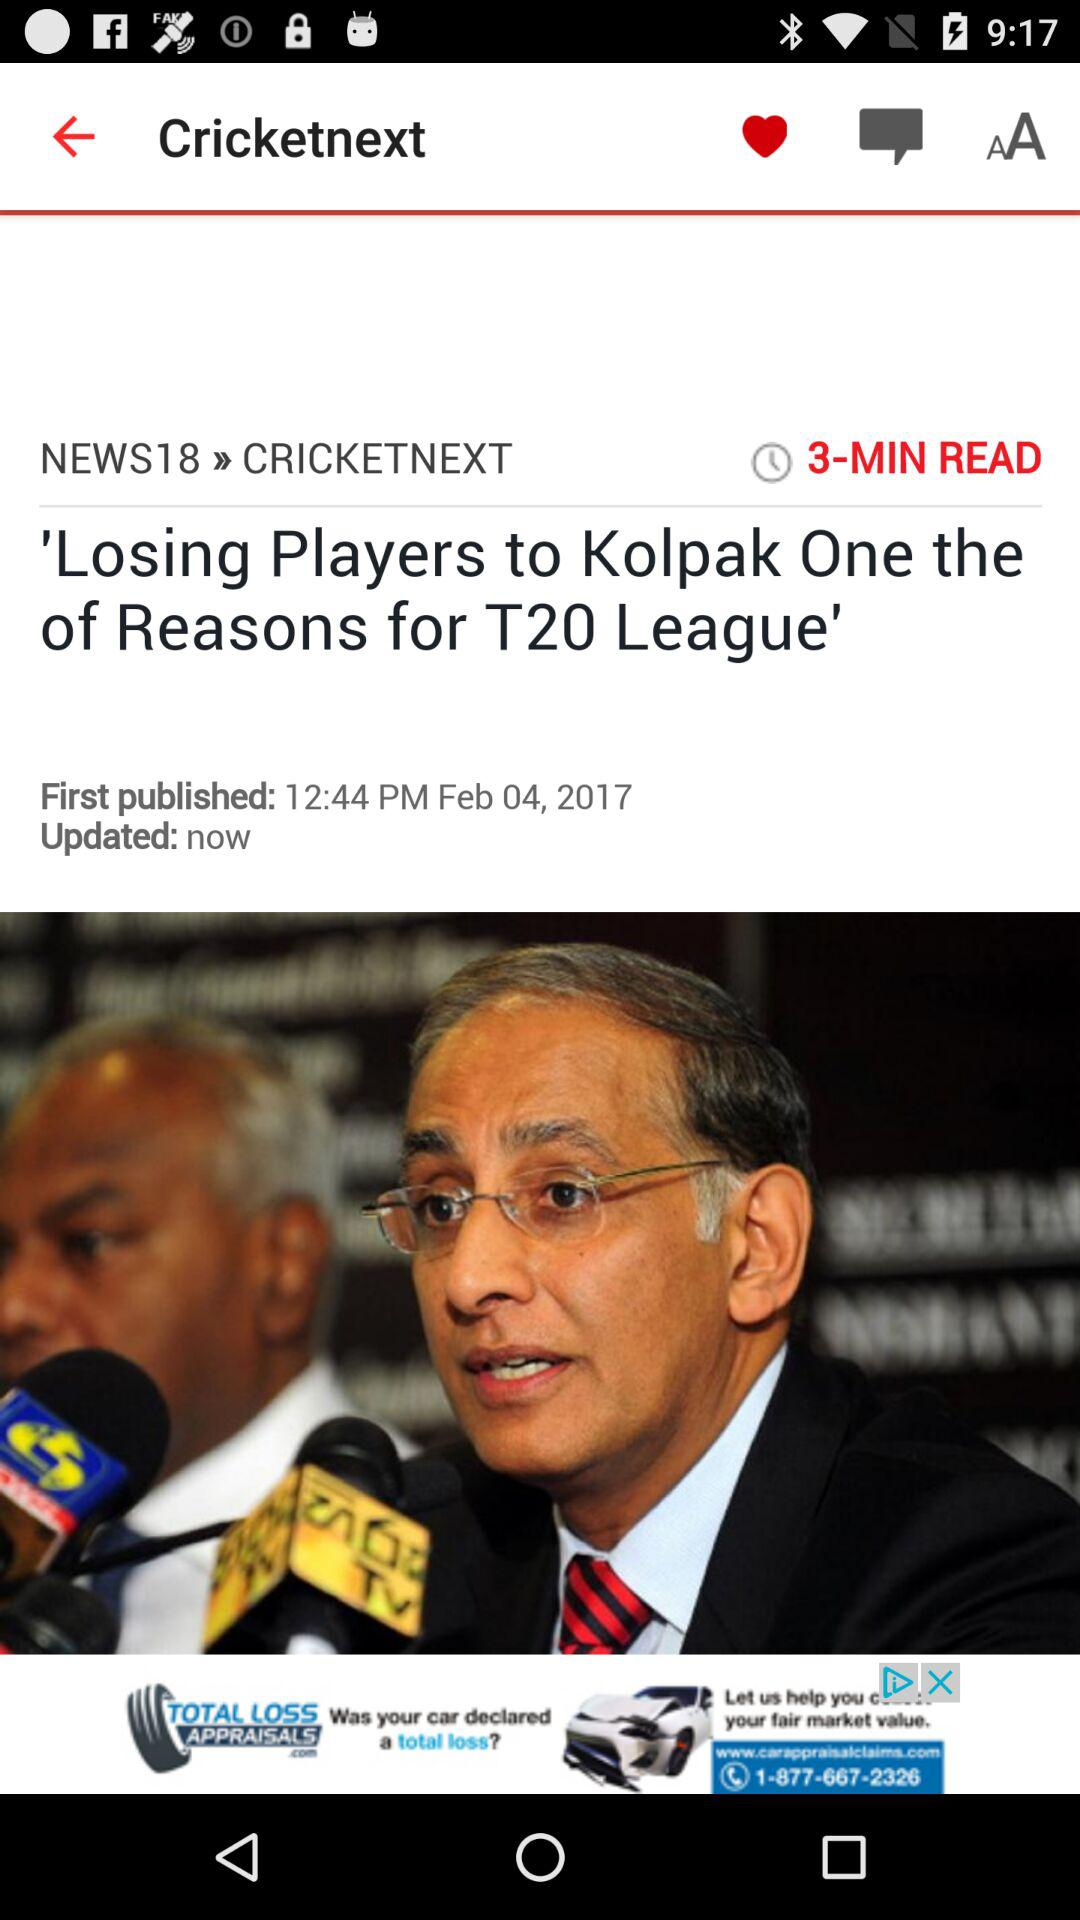When was the news first published? The news was first published on February 4, 2017 at 12:44 PM. 